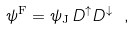<formula> <loc_0><loc_0><loc_500><loc_500>\psi ^ { \text  F} = \psi_{\text  J} \, D^{\uparrow} D^{\downarrow} \ ,</formula> 